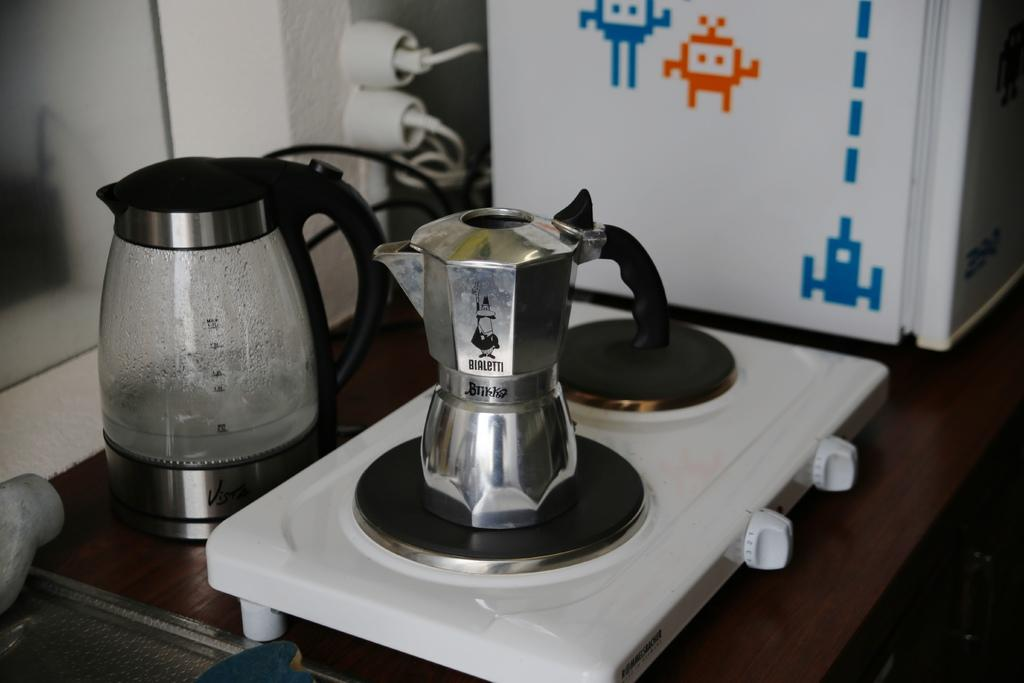<image>
Summarize the visual content of the image. A coffee pot has the name Bialetti on it in black lettering. 